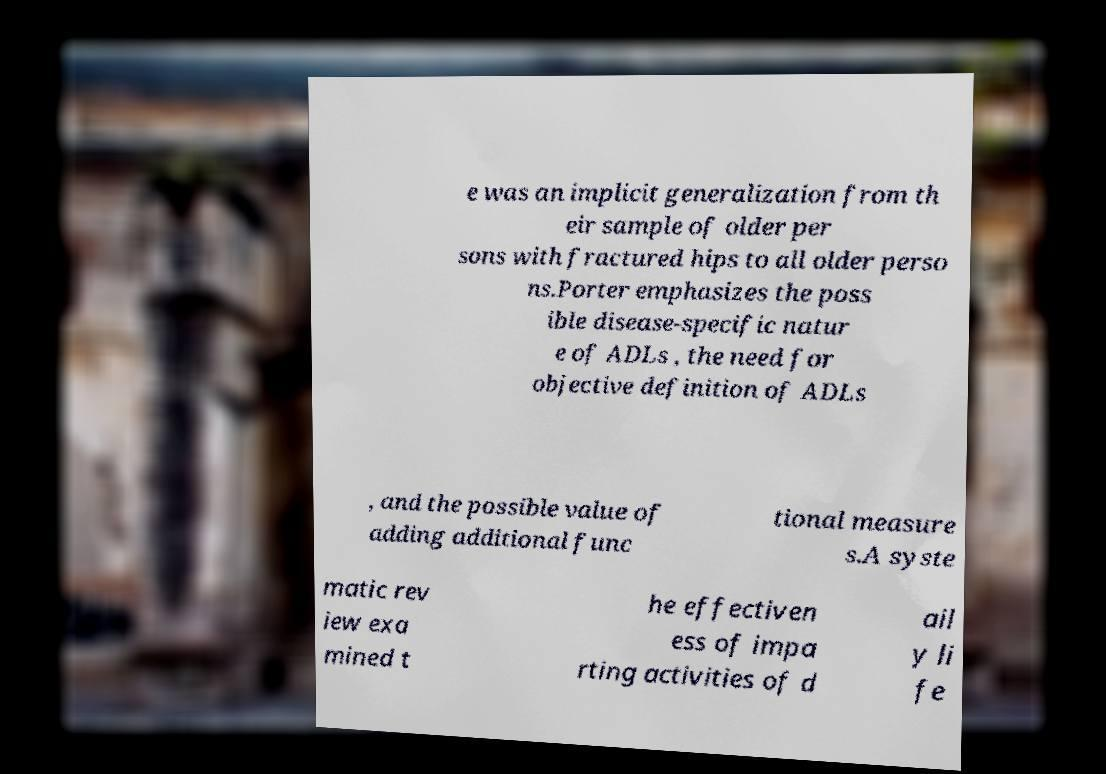Please identify and transcribe the text found in this image. e was an implicit generalization from th eir sample of older per sons with fractured hips to all older perso ns.Porter emphasizes the poss ible disease-specific natur e of ADLs , the need for objective definition of ADLs , and the possible value of adding additional func tional measure s.A syste matic rev iew exa mined t he effectiven ess of impa rting activities of d ail y li fe 